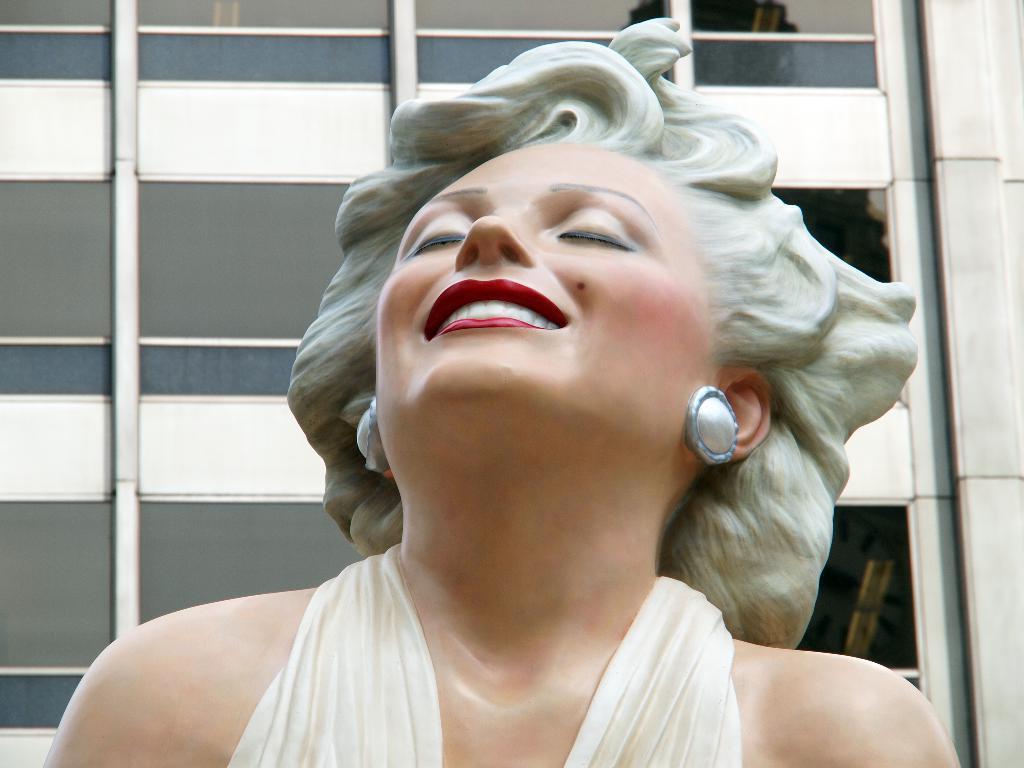Please provide a concise description of this image. In this picture we can see the statue of a woman and behind the woman there is a building. 